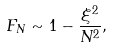<formula> <loc_0><loc_0><loc_500><loc_500>F _ { N } \sim 1 - \frac { \xi ^ { 2 } } { N ^ { 2 } } ,</formula> 